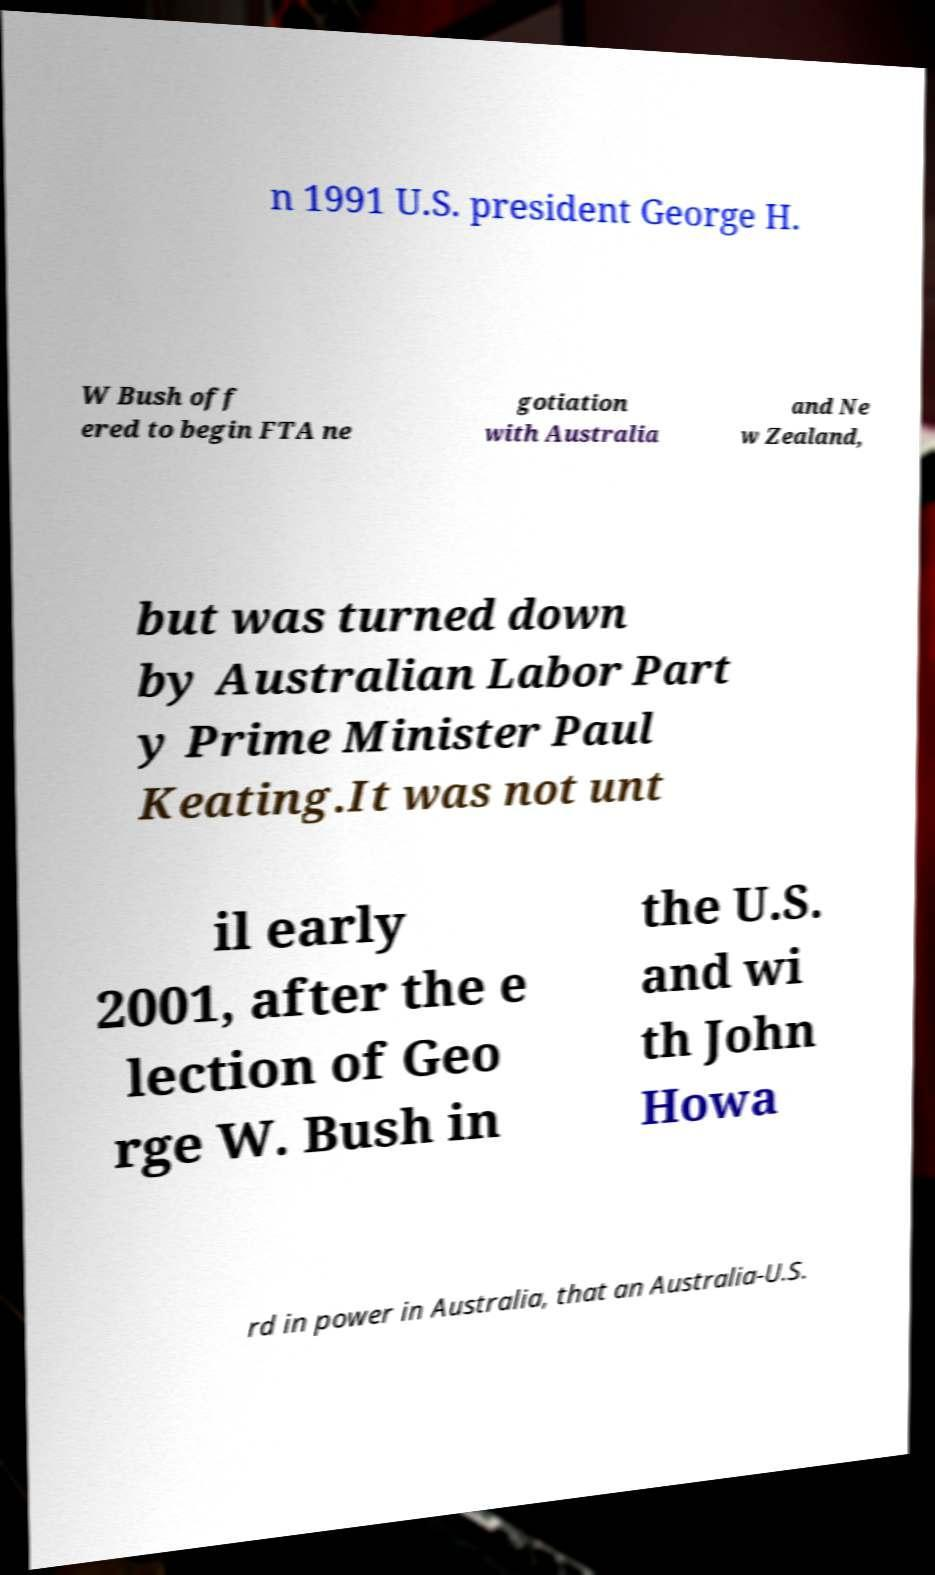Please identify and transcribe the text found in this image. n 1991 U.S. president George H. W Bush off ered to begin FTA ne gotiation with Australia and Ne w Zealand, but was turned down by Australian Labor Part y Prime Minister Paul Keating.It was not unt il early 2001, after the e lection of Geo rge W. Bush in the U.S. and wi th John Howa rd in power in Australia, that an Australia-U.S. 